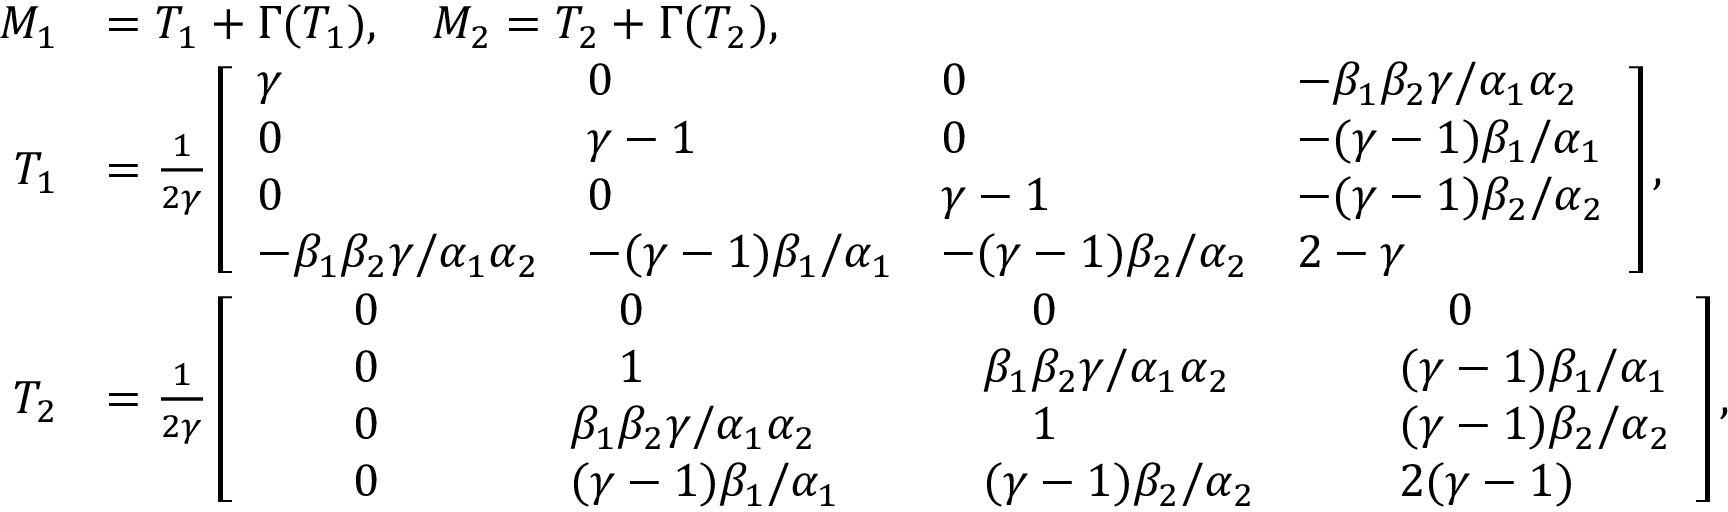<formula> <loc_0><loc_0><loc_500><loc_500>\begin{array} { r } { \begin{array} { r l } { M _ { 1 } } & { = T _ { 1 } + \Gamma ( T _ { 1 } ) , \quad M _ { 2 } = T _ { 2 } + \Gamma ( T _ { 2 } ) , } \\ { T _ { 1 } } & { = \frac { 1 } { 2 \gamma } \left [ \begin{array} { l l l l } { \gamma } & { 0 } & { 0 } & { - \beta _ { 1 } \beta _ { 2 } \gamma / \alpha _ { 1 } \alpha _ { 2 } } \\ { 0 } & { \gamma - 1 } & { 0 } & { - ( \gamma - 1 ) \beta _ { 1 } / \alpha _ { 1 } } \\ { 0 } & { 0 } & { \gamma - 1 } & { - ( \gamma - 1 ) \beta _ { 2 } / \alpha _ { 2 } } \\ { - \beta _ { 1 } \beta _ { 2 } \gamma / \alpha _ { 1 } \alpha _ { 2 } } & { - ( \gamma - 1 ) \beta _ { 1 } / \alpha _ { 1 } } & { - ( \gamma - 1 ) \beta _ { 2 } / \alpha _ { 2 } } & { 2 - \gamma } \end{array} \right ] , } \\ { T _ { 2 } } & { = \frac { 1 } { 2 \gamma } \left [ \begin{array} { l l l l } { \quad 0 \quad } & { \quad 0 \quad } & { \quad 0 \quad } & { \quad 0 } \\ { \quad 0 \quad } & { \quad 1 \quad } & { \quad \beta _ { 1 } \beta _ { 2 } \gamma / \alpha _ { 1 } \alpha _ { 2 } \quad } & { \quad ( \gamma - 1 ) \beta _ { 1 } / \alpha _ { 1 } } \\ { \quad 0 \quad } & { \quad \beta _ { 1 } \beta _ { 2 } \gamma / \alpha _ { 1 } \alpha _ { 2 } \quad } & { \quad 1 \quad } & { \quad ( \gamma - 1 ) \beta _ { 2 } / \alpha _ { 2 } } \\ { \quad 0 \quad } & { \quad ( \gamma - 1 ) \beta _ { 1 } / \alpha _ { 1 } \quad } & { \quad ( \gamma - 1 ) \beta _ { 2 } / \alpha _ { 2 } \quad } & { \quad 2 ( \gamma - 1 ) } \end{array} \right ] , } \end{array} } \end{array}</formula> 